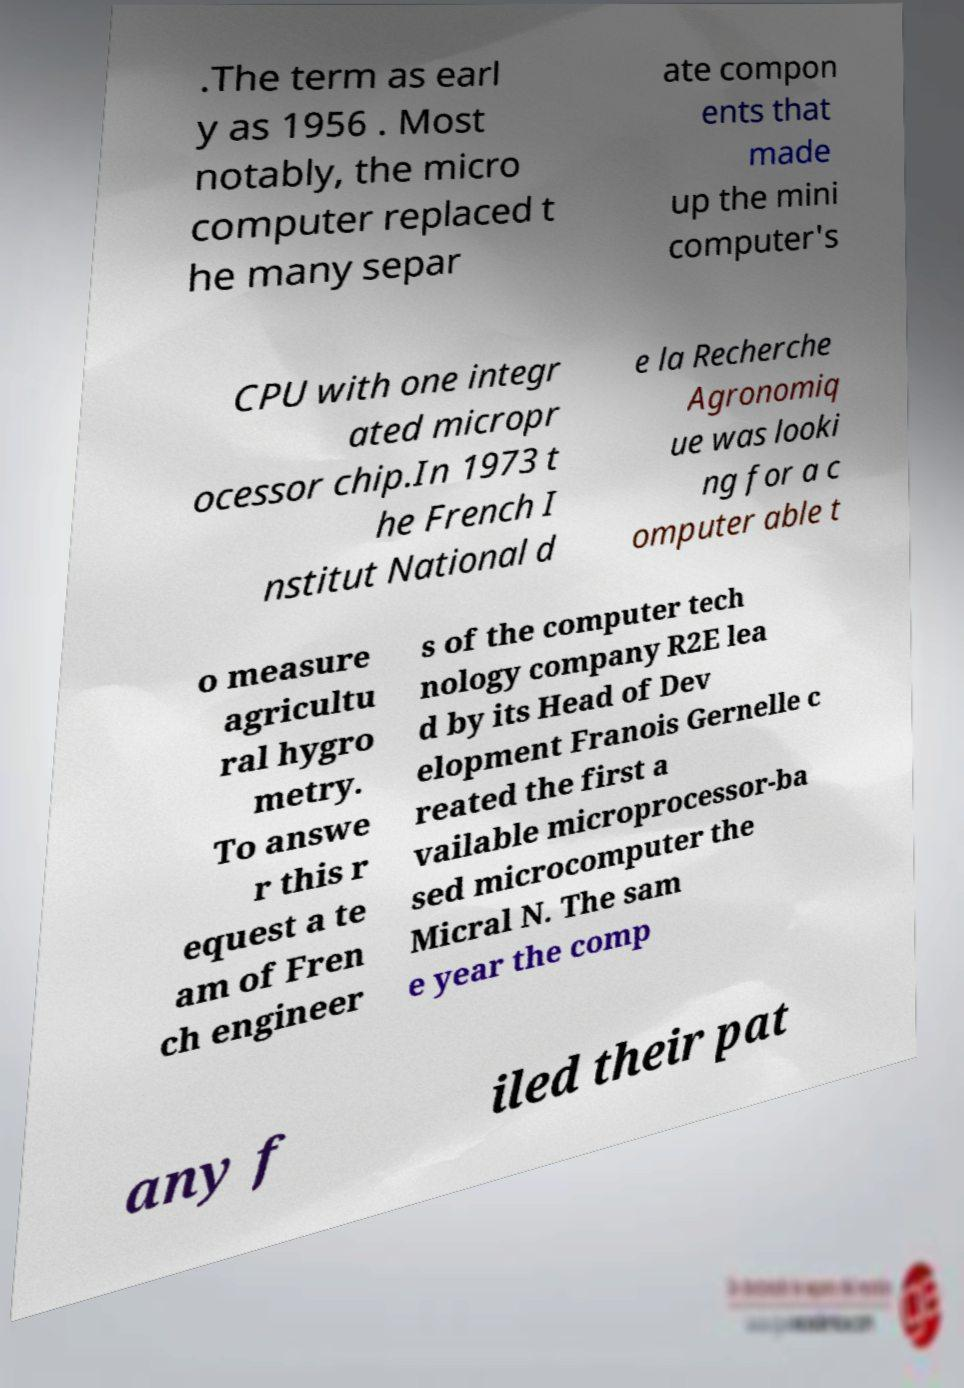Could you extract and type out the text from this image? .The term as earl y as 1956 . Most notably, the micro computer replaced t he many separ ate compon ents that made up the mini computer's CPU with one integr ated micropr ocessor chip.In 1973 t he French I nstitut National d e la Recherche Agronomiq ue was looki ng for a c omputer able t o measure agricultu ral hygro metry. To answe r this r equest a te am of Fren ch engineer s of the computer tech nology company R2E lea d by its Head of Dev elopment Franois Gernelle c reated the first a vailable microprocessor-ba sed microcomputer the Micral N. The sam e year the comp any f iled their pat 